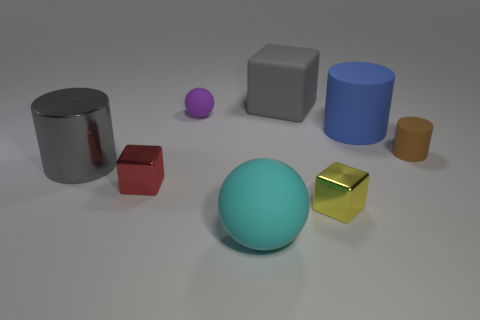Subtract all large blocks. How many blocks are left? 2 Add 2 brown rubber cylinders. How many objects exist? 10 Subtract all blue cylinders. How many cylinders are left? 2 Add 6 big gray blocks. How many big gray blocks are left? 7 Add 7 big gray metallic objects. How many big gray metallic objects exist? 8 Subtract 0 green cubes. How many objects are left? 8 Subtract all cubes. How many objects are left? 5 Subtract 3 cylinders. How many cylinders are left? 0 Subtract all purple balls. Subtract all purple blocks. How many balls are left? 1 Subtract all gray blocks. How many blue cylinders are left? 1 